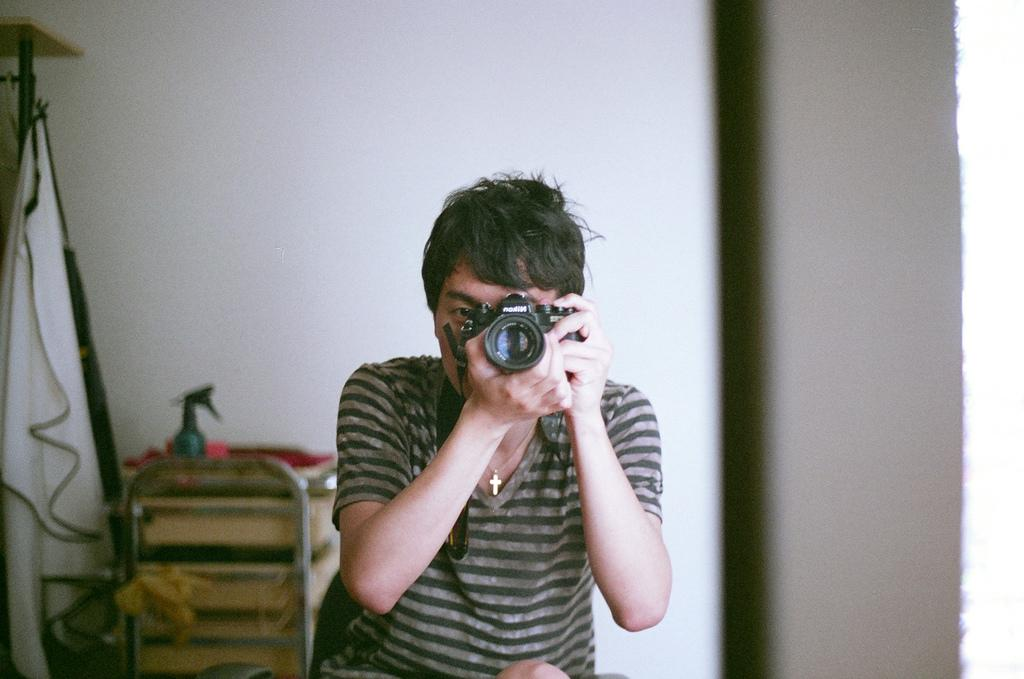Who is the main subject in the image? There is a man in the image. What is the man holding in the image? The man is holding a camera. What is the man doing with the camera? The man is clicking pictures. What can be seen in the background of the image? There are unspecified things in the background of the image. How many seats can be seen in the image? There is no mention of seats in the image, so it is not possible to determine their number. 